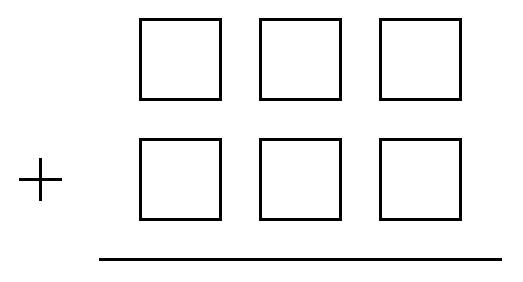Can you create the largest possible sum using these numbers in the addition problem? To generate the largest sum, the largest digits should be placed in the most significant places of each 3-digit number. Therefore, the best distribution would be to arrange them as 987 and 654, which totals 1641. 